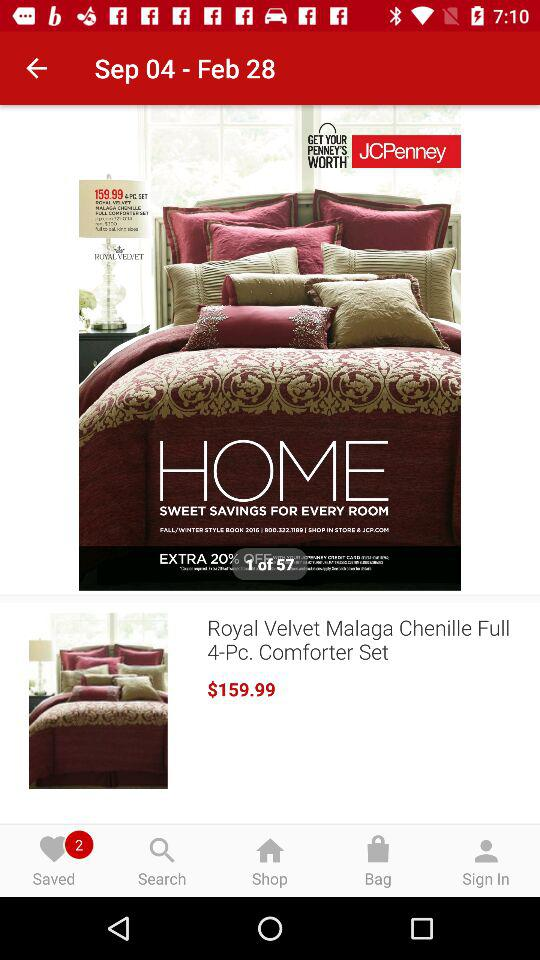How many items are there in the "Saved" option? There are 2 items in the "Saved" option. 